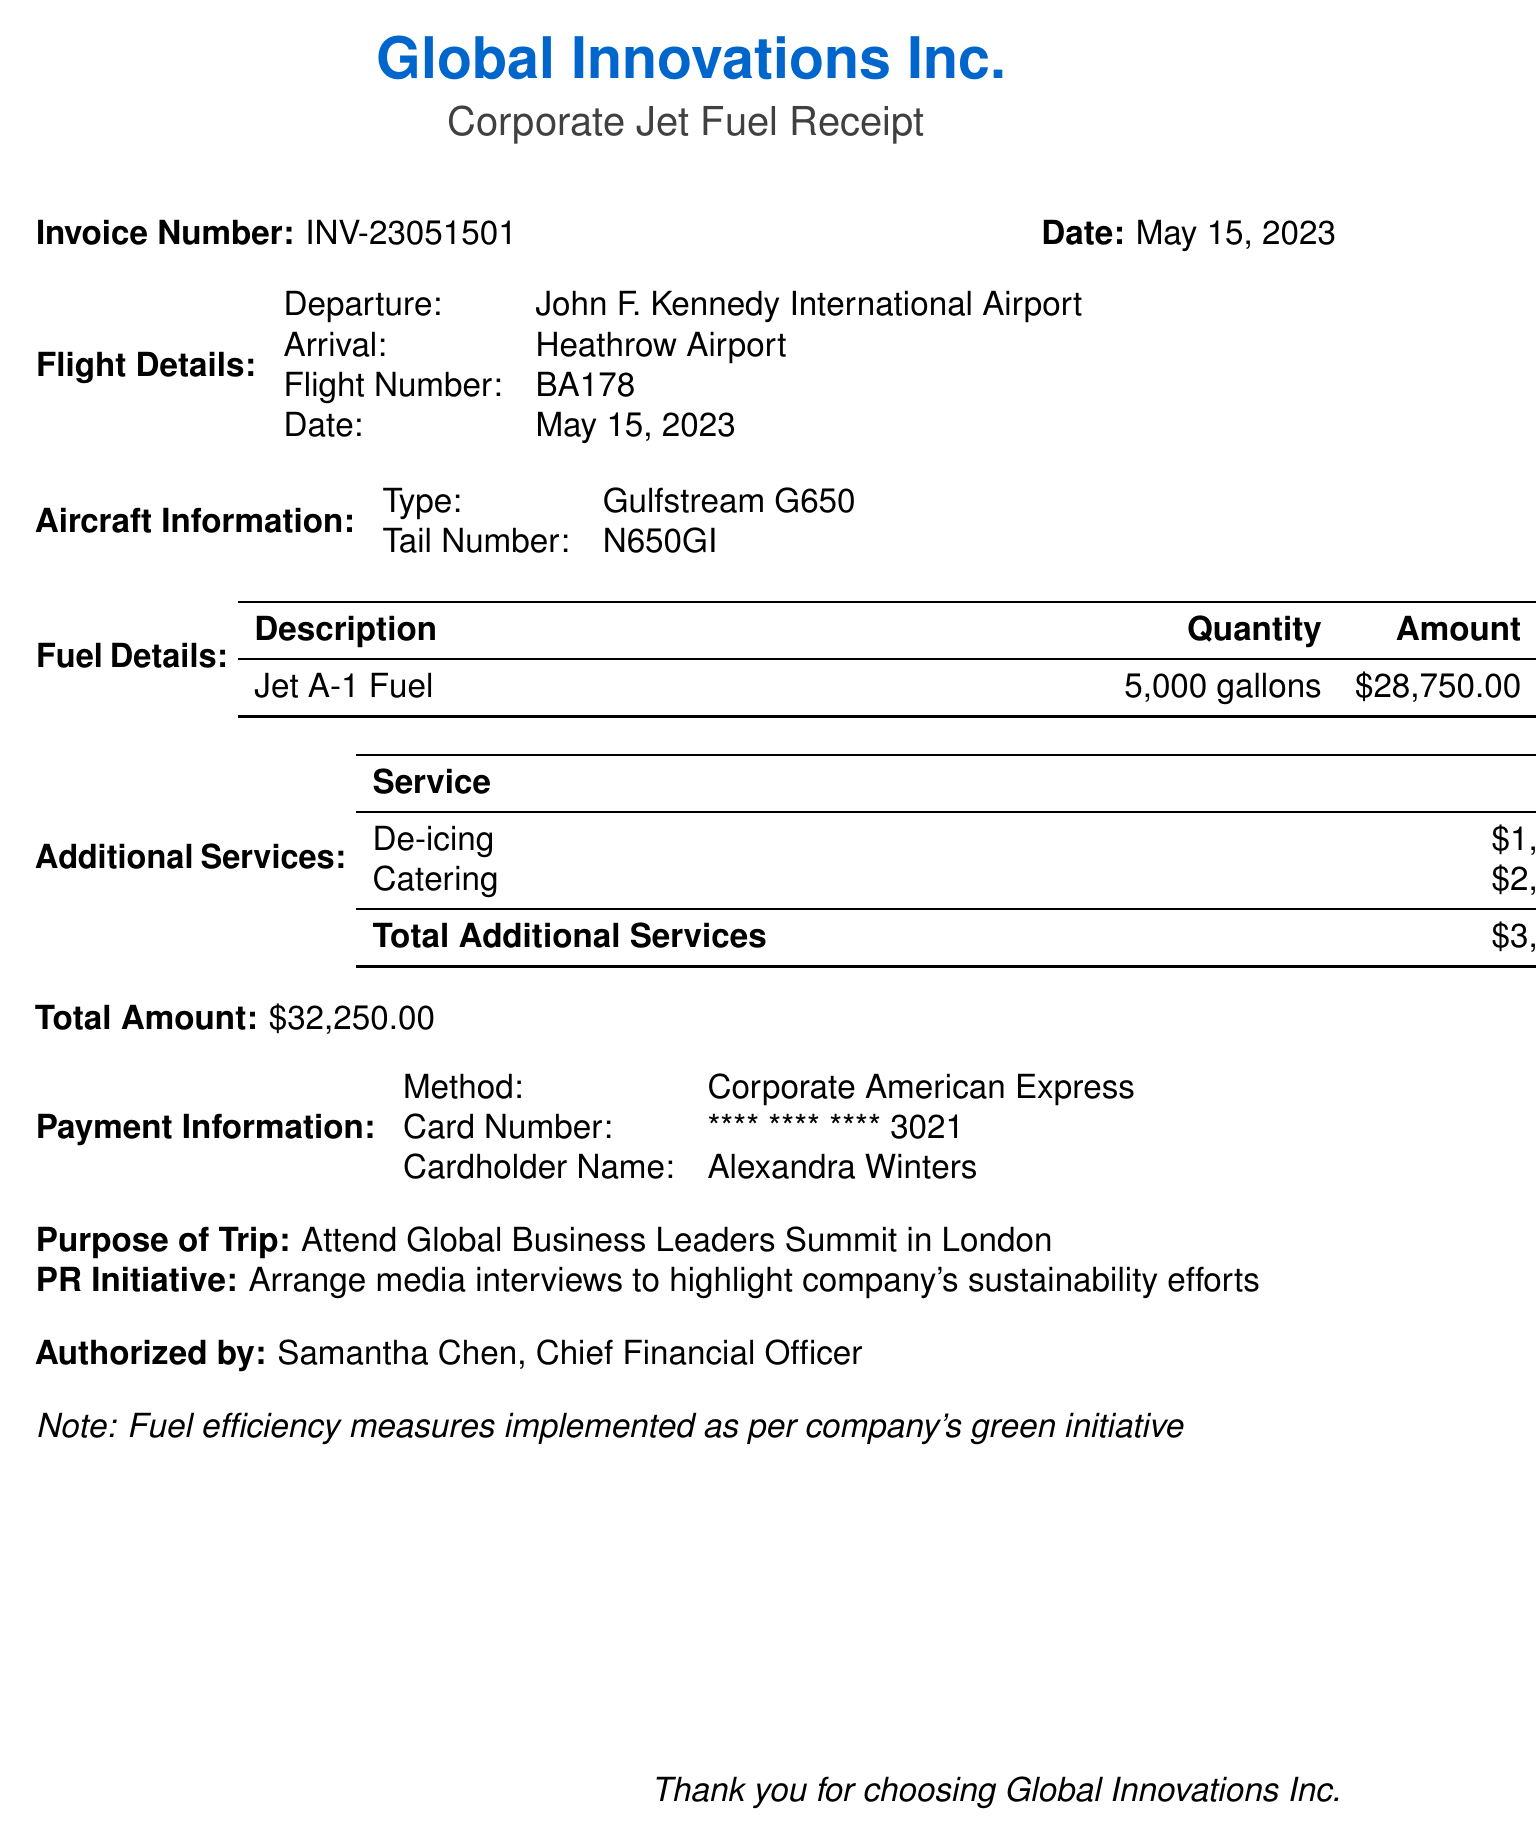What is the company name? The document states the company's name prominently at the top.
Answer: Global Innovations Inc What is the flight number? The flight number is listed under the flight details section of the document.
Answer: BA178 What is the total fuel cost? The total fuel cost is calculated based on the quantity and price per gallon mentioned.
Answer: 28750 What is the purpose of the trip? The purpose is explicitly stated in the designated section of the document.
Answer: Attend Global Business Leaders Summit in London How many gallons of fuel were purchased? The quantity of fuel is detailed under the fuel details section.
Answer: 5000 What additional service cost the most? The additional services section provides the costs for each service, allowing for comparison.
Answer: Catering Who authorized the payment? The document specifies the individual who authorized the transaction under the authorized by section.
Answer: Samantha Chen, Chief Financial Officer What type of aircraft was used? The type of aircraft is noted in the aircraft information section.
Answer: Gulfstream G650 What is the payment method? The method of payment is indicated in the payment information section.
Answer: Corporate American Express What is the transaction date? The date of the transaction is listed prominently in the document.
Answer: 2023-05-15 